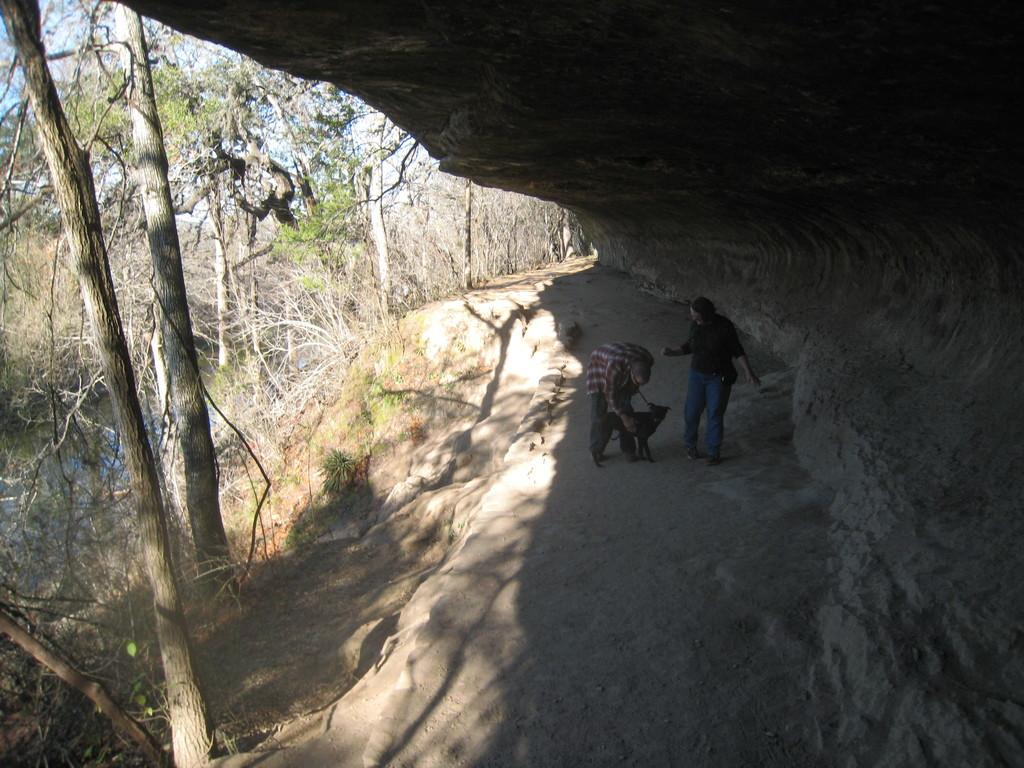How many people are in the image? There are two people in the image. What other living creature is present in the image? There is a dog in the image. Where are the people and the dog located? The people and the dog are on the ground. What object can be seen in the image? There is a rock in the image. What can be seen in the background of the image? There are trees in the background of the image. What type of tax is being discussed by the people in the image? There is no indication in the image that the people are discussing any type of tax. 